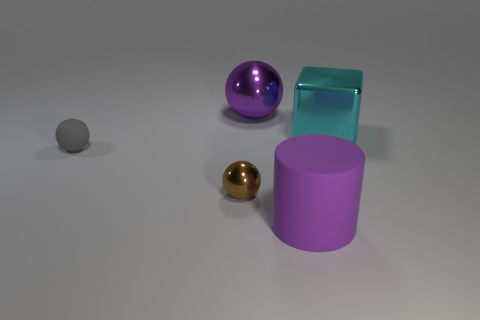Which object seems to be the lightest in weight? If appearances are anything to go by, the small gray sphere on the left seems to be the lightest in weight due to its size and the fact that it's the smallest object. However, appearances can be deceiving without knowing the exact materials. 